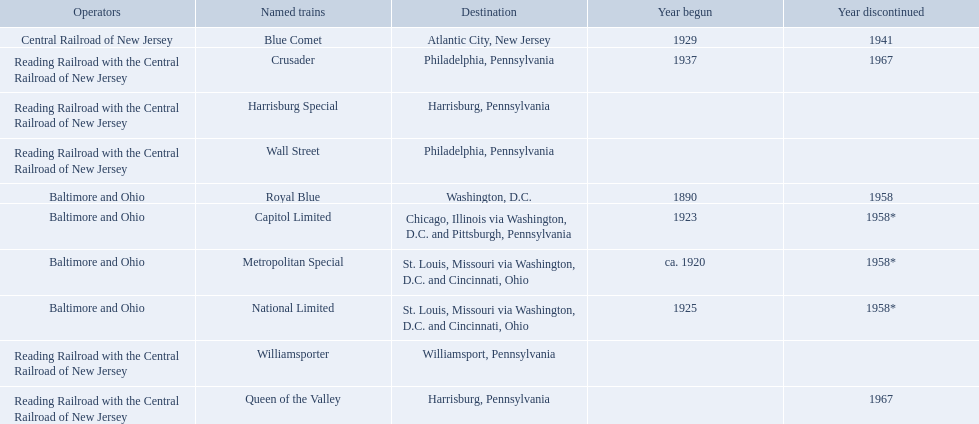What are the destinations of the central railroad of new jersey terminal? Chicago, Illinois via Washington, D.C. and Pittsburgh, Pennsylvania, St. Louis, Missouri via Washington, D.C. and Cincinnati, Ohio, St. Louis, Missouri via Washington, D.C. and Cincinnati, Ohio, Washington, D.C., Atlantic City, New Jersey, Philadelphia, Pennsylvania, Harrisburg, Pennsylvania, Harrisburg, Pennsylvania, Philadelphia, Pennsylvania, Williamsport, Pennsylvania. Which of these destinations is at the top of the list? Chicago, Illinois via Washington, D.C. and Pittsburgh, Pennsylvania. 